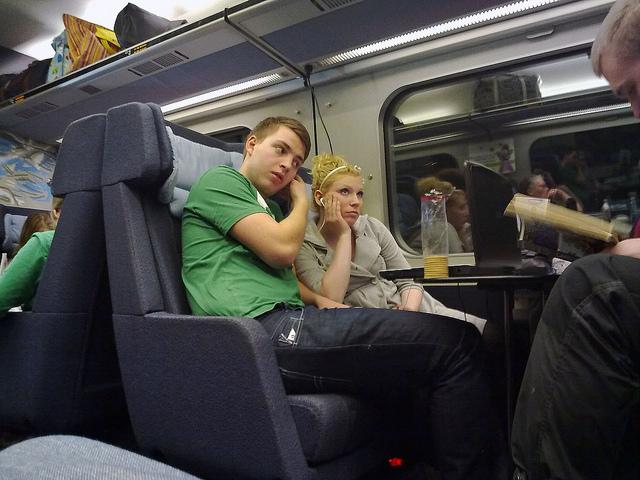What mode of transportation is this?
Quick response, please. Train. Where did the lady get her drink?
Keep it brief. Store. What are these people doing?
Keep it brief. Sitting. Are they both women?
Give a very brief answer. No. 